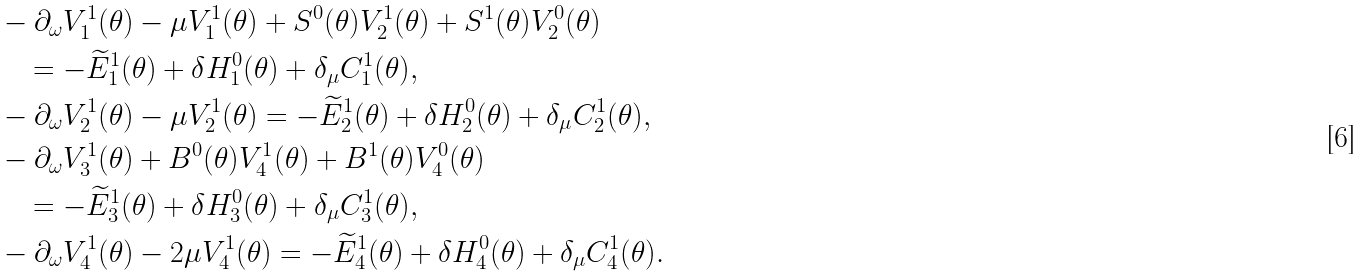Convert formula to latex. <formula><loc_0><loc_0><loc_500><loc_500>& - \partial _ { \omega } V _ { 1 } ^ { 1 } ( \theta ) - \mu V _ { 1 } ^ { 1 } ( \theta ) + S ^ { 0 } ( \theta ) V _ { 2 } ^ { 1 } ( \theta ) + S ^ { 1 } ( \theta ) V _ { 2 } ^ { 0 } ( \theta ) \\ & \quad = - \widetilde { E } _ { 1 } ^ { 1 } ( \theta ) + \delta H _ { 1 } ^ { 0 } ( \theta ) + \delta _ { \mu } C _ { 1 } ^ { 1 } ( \theta ) , \\ & - \partial _ { \omega } V _ { 2 } ^ { 1 } ( \theta ) - \mu V _ { 2 } ^ { 1 } ( \theta ) = - \widetilde { E } _ { 2 } ^ { 1 } ( \theta ) + \delta H _ { 2 } ^ { 0 } ( \theta ) + \delta _ { \mu } C _ { 2 } ^ { 1 } ( \theta ) , \\ & - \partial _ { \omega } V _ { 3 } ^ { 1 } ( \theta ) + B ^ { 0 } ( \theta ) V _ { 4 } ^ { 1 } ( \theta ) + B ^ { 1 } ( \theta ) V _ { 4 } ^ { 0 } ( \theta ) \\ & \quad = - \widetilde { E } _ { 3 } ^ { 1 } ( \theta ) + \delta H _ { 3 } ^ { 0 } ( \theta ) + \delta _ { \mu } C _ { 3 } ^ { 1 } ( \theta ) , \\ & - \partial _ { \omega } V _ { 4 } ^ { 1 } ( \theta ) - 2 \mu V _ { 4 } ^ { 1 } ( \theta ) = - \widetilde { E } _ { 4 } ^ { 1 } ( \theta ) + \delta H _ { 4 } ^ { 0 } ( \theta ) + \delta _ { \mu } C _ { 4 } ^ { 1 } ( \theta ) .</formula> 